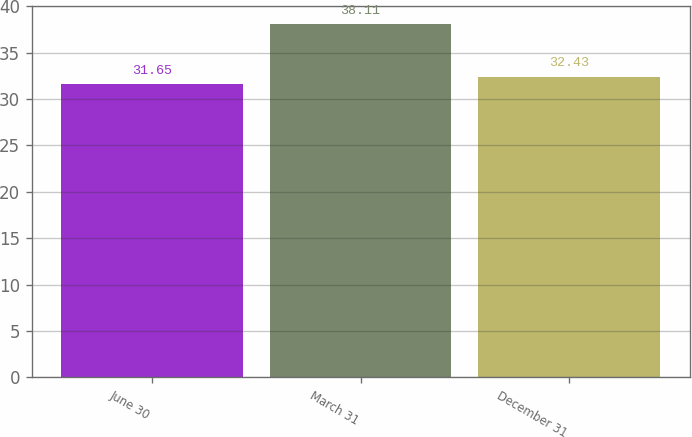Convert chart to OTSL. <chart><loc_0><loc_0><loc_500><loc_500><bar_chart><fcel>June 30<fcel>March 31<fcel>December 31<nl><fcel>31.65<fcel>38.11<fcel>32.43<nl></chart> 